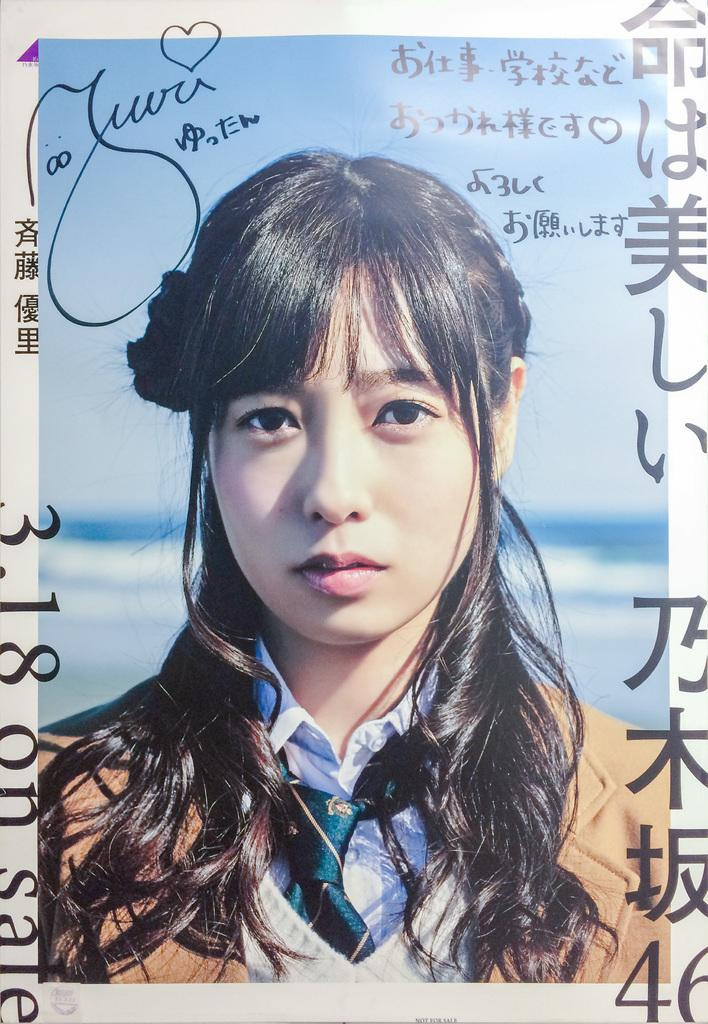What is the main subject of the image? The main subject of the image is a photo of a girl. Are there any additional details on the photo? Yes, there are writings on the photo of the girl. What type of island can be seen in the background of the photo? There is no island visible in the image, as it only features a photo of a girl with writings on it. 